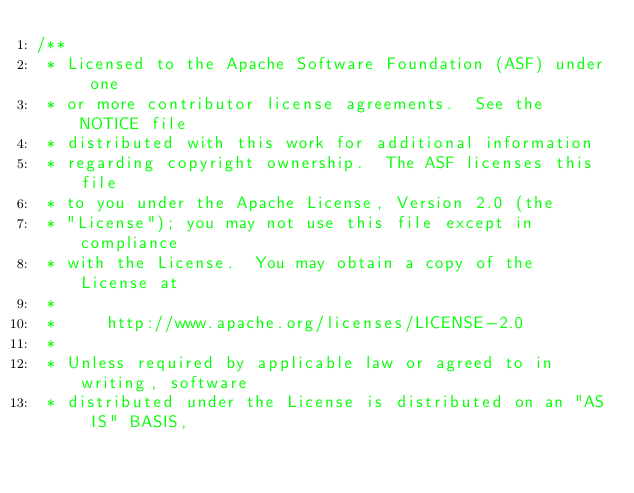Convert code to text. <code><loc_0><loc_0><loc_500><loc_500><_Java_>/**
 * Licensed to the Apache Software Foundation (ASF) under one
 * or more contributor license agreements.  See the NOTICE file
 * distributed with this work for additional information
 * regarding copyright ownership.  The ASF licenses this file
 * to you under the Apache License, Version 2.0 (the
 * "License"); you may not use this file except in compliance
 * with the License.  You may obtain a copy of the License at
 *
 *     http://www.apache.org/licenses/LICENSE-2.0
 *
 * Unless required by applicable law or agreed to in writing, software
 * distributed under the License is distributed on an "AS IS" BASIS,</code> 